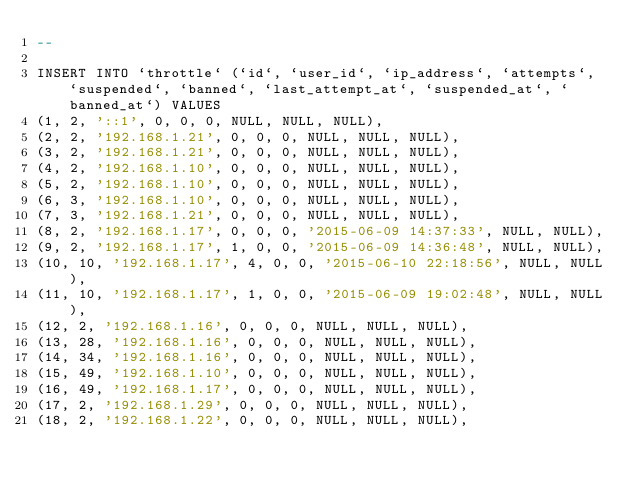<code> <loc_0><loc_0><loc_500><loc_500><_SQL_>--

INSERT INTO `throttle` (`id`, `user_id`, `ip_address`, `attempts`, `suspended`, `banned`, `last_attempt_at`, `suspended_at`, `banned_at`) VALUES
(1, 2, '::1', 0, 0, 0, NULL, NULL, NULL),
(2, 2, '192.168.1.21', 0, 0, 0, NULL, NULL, NULL),
(3, 2, '192.168.1.21', 0, 0, 0, NULL, NULL, NULL),
(4, 2, '192.168.1.10', 0, 0, 0, NULL, NULL, NULL),
(5, 2, '192.168.1.10', 0, 0, 0, NULL, NULL, NULL),
(6, 3, '192.168.1.10', 0, 0, 0, NULL, NULL, NULL),
(7, 3, '192.168.1.21', 0, 0, 0, NULL, NULL, NULL),
(8, 2, '192.168.1.17', 0, 0, 0, '2015-06-09 14:37:33', NULL, NULL),
(9, 2, '192.168.1.17', 1, 0, 0, '2015-06-09 14:36:48', NULL, NULL),
(10, 10, '192.168.1.17', 4, 0, 0, '2015-06-10 22:18:56', NULL, NULL),
(11, 10, '192.168.1.17', 1, 0, 0, '2015-06-09 19:02:48', NULL, NULL),
(12, 2, '192.168.1.16', 0, 0, 0, NULL, NULL, NULL),
(13, 28, '192.168.1.16', 0, 0, 0, NULL, NULL, NULL),
(14, 34, '192.168.1.16', 0, 0, 0, NULL, NULL, NULL),
(15, 49, '192.168.1.10', 0, 0, 0, NULL, NULL, NULL),
(16, 49, '192.168.1.17', 0, 0, 0, NULL, NULL, NULL),
(17, 2, '192.168.1.29', 0, 0, 0, NULL, NULL, NULL),
(18, 2, '192.168.1.22', 0, 0, 0, NULL, NULL, NULL),</code> 